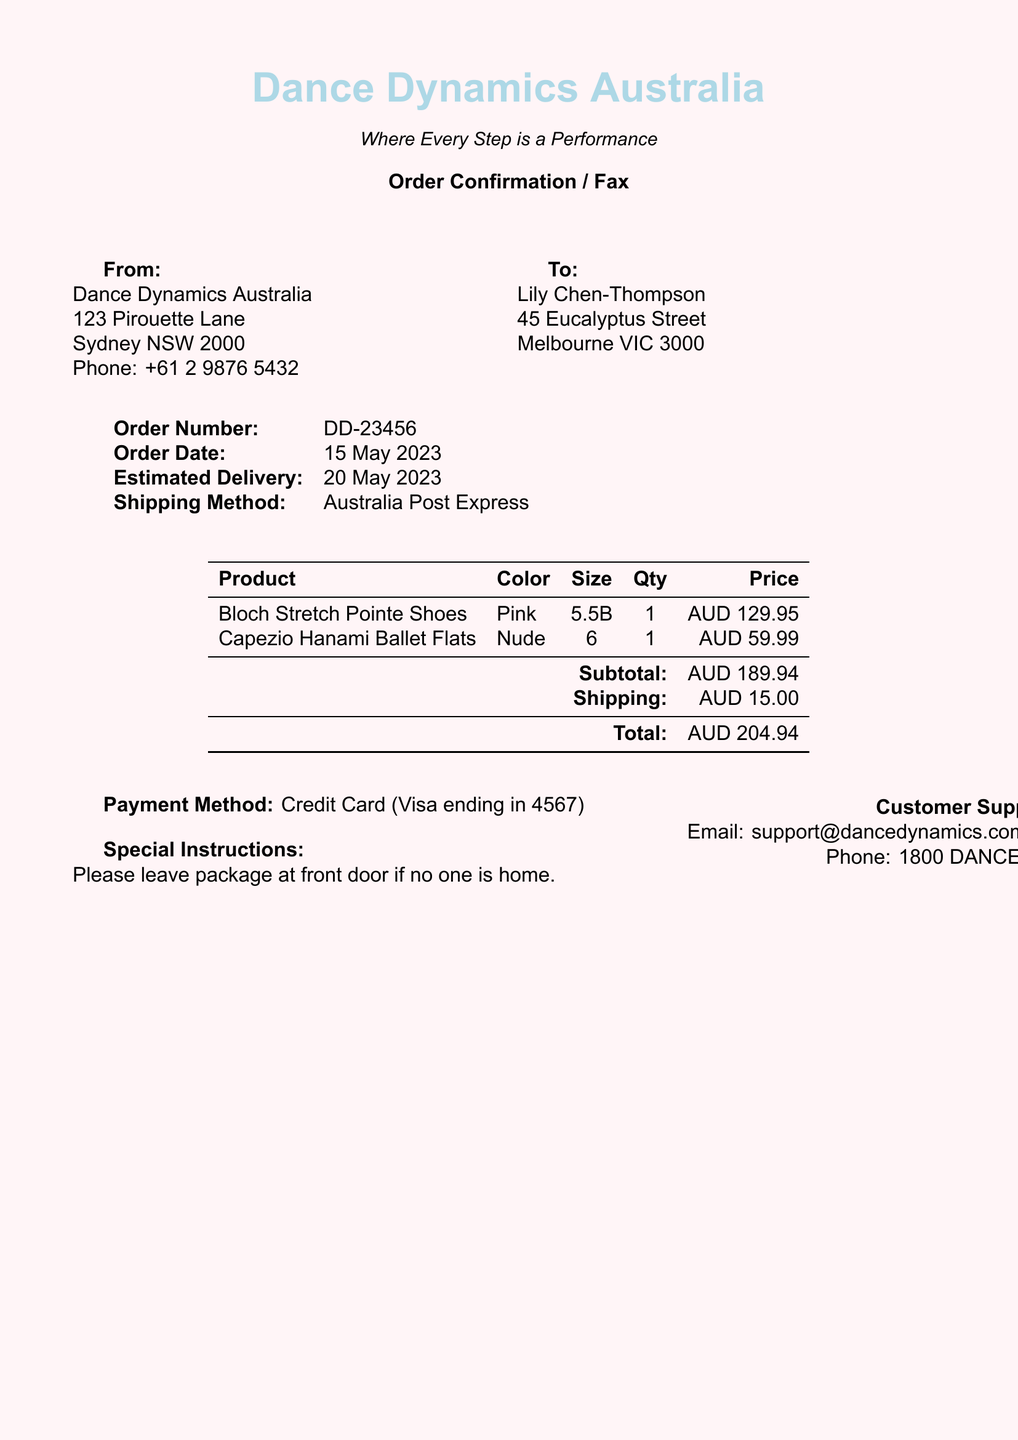What is the order number? The order number is a unique identifier for this transaction found at the beginning of the order details.
Answer: DD-23456 What is the estimated delivery date? The estimated delivery date is provided in the order confirmation section and indicates when the items are expected to arrive.
Answer: 20 May 2023 Who is the recipient of the order? The recipient's name is stated in the 'To' section of the document, identifying who the order is for.
Answer: Lily Chen-Thompson What is the subtotal for the order? The subtotal refers to the sum of the items before shipping costs are added, which is specified in the pricing table.
Answer: AUD 189.94 What shipping method is used? The shipping method describes how the items will be sent and is mentioned in the order details section.
Answer: Australia Post Express How many items of Bloch Stretch Pointe Shoes were ordered? This question refers to the quantity column in the product table to determine the number of pairs ordered.
Answer: 1 What color are the Capezio Hanami Ballet Flats? The color is specified in the product table, detailing the characteristics of the ordered items.
Answer: Nude What payment method was used for the order? The payment method details how the transaction was completed and can be found in the payment section.
Answer: Credit Card (Visa ending in 4567) What special instructions were given? Special instructions provide guidance for delivery and are usually placed towards the end of the document.
Answer: Please leave package at front door if no one is home What is the total amount for the order? The total amount includes the subtotal plus shipping costs and is clearly indicated in the pricing section.
Answer: AUD 204.94 